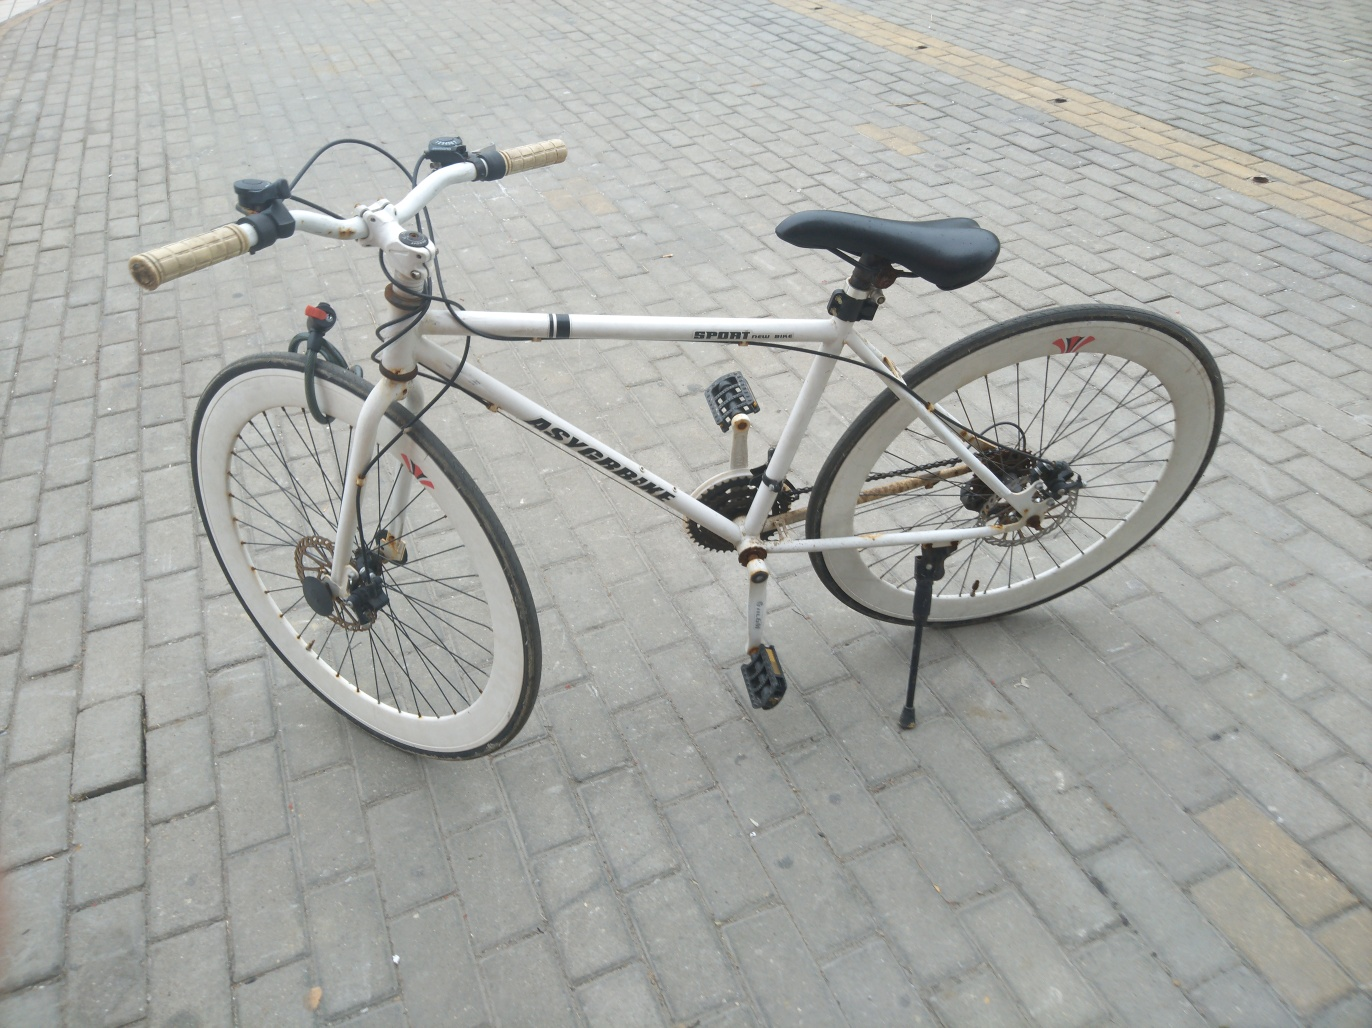Does the image have good lighting? The image features adequate lighting, which allows for clear visibility of the bicycle and the details of its frame, wheels, and components. There are no harsh shadows obscuring the view, and the natural light provides a soft illumination without overexposure. 